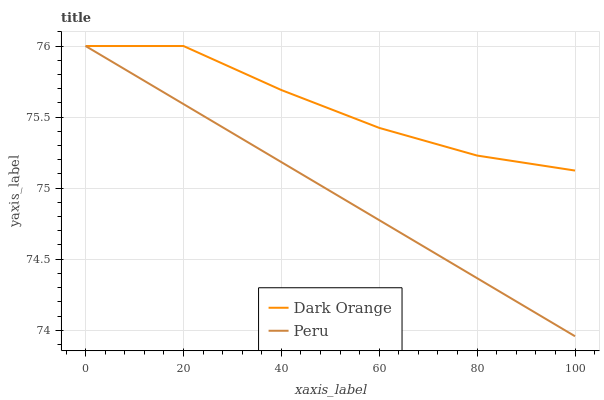Does Peru have the minimum area under the curve?
Answer yes or no. Yes. Does Dark Orange have the maximum area under the curve?
Answer yes or no. Yes. Does Peru have the maximum area under the curve?
Answer yes or no. No. Is Peru the smoothest?
Answer yes or no. Yes. Is Dark Orange the roughest?
Answer yes or no. Yes. Is Peru the roughest?
Answer yes or no. No. Does Peru have the lowest value?
Answer yes or no. Yes. Does Peru have the highest value?
Answer yes or no. Yes. Does Peru intersect Dark Orange?
Answer yes or no. Yes. Is Peru less than Dark Orange?
Answer yes or no. No. Is Peru greater than Dark Orange?
Answer yes or no. No. 